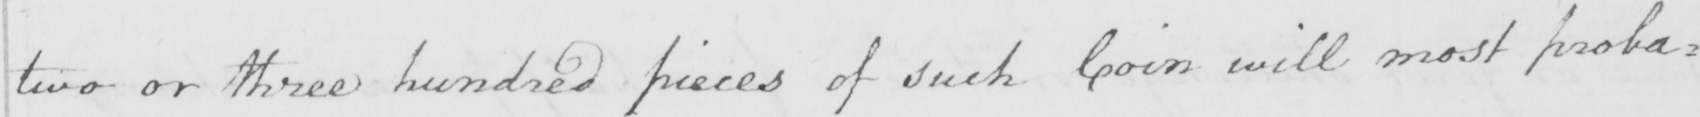Please transcribe the handwritten text in this image. two or three hundred pieces of such Coin will most proba= 